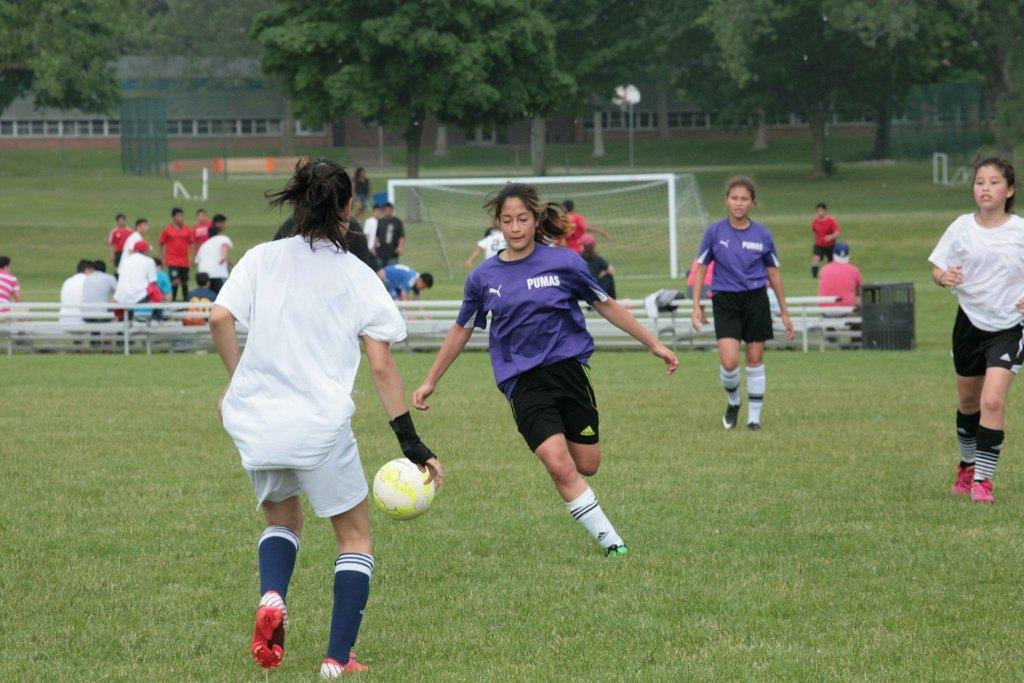<image>
Describe the image concisely. A woman wearing a Pumas shirt goes after the soccer ball. 